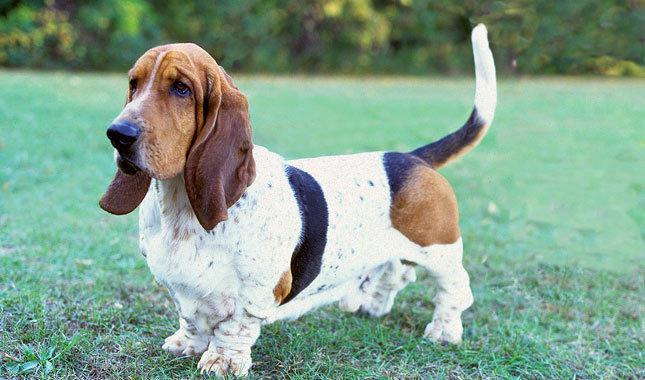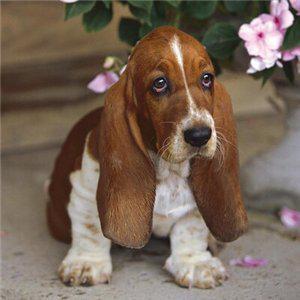The first image is the image on the left, the second image is the image on the right. Given the left and right images, does the statement "In one of the images there is a basset hound puppy sitting." hold true? Answer yes or no. Yes. 